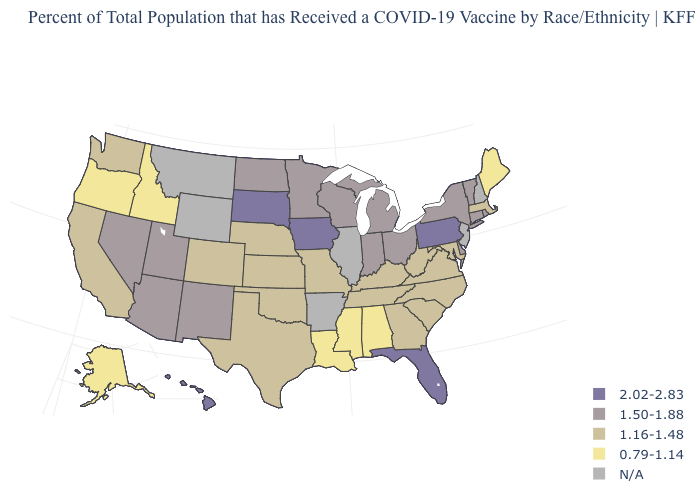What is the lowest value in the West?
Keep it brief. 0.79-1.14. What is the highest value in the USA?
Concise answer only. 2.02-2.83. Name the states that have a value in the range 0.79-1.14?
Answer briefly. Alabama, Alaska, Idaho, Louisiana, Maine, Mississippi, Oregon. What is the value of Kentucky?
Concise answer only. 1.16-1.48. What is the value of Iowa?
Answer briefly. 2.02-2.83. What is the highest value in the USA?
Give a very brief answer. 2.02-2.83. What is the highest value in the USA?
Give a very brief answer. 2.02-2.83. Name the states that have a value in the range 1.50-1.88?
Write a very short answer. Arizona, Connecticut, Delaware, Indiana, Michigan, Minnesota, Nevada, New Mexico, New York, North Dakota, Ohio, Rhode Island, Utah, Vermont, Wisconsin. What is the value of Washington?
Give a very brief answer. 1.16-1.48. Among the states that border South Carolina , which have the lowest value?
Be succinct. Georgia, North Carolina. Among the states that border Delaware , does Pennsylvania have the highest value?
Quick response, please. Yes. Does Florida have the highest value in the South?
Concise answer only. Yes. What is the lowest value in states that border Oklahoma?
Answer briefly. 1.16-1.48. Which states have the lowest value in the USA?
Write a very short answer. Alabama, Alaska, Idaho, Louisiana, Maine, Mississippi, Oregon. Does Iowa have the highest value in the USA?
Quick response, please. Yes. 